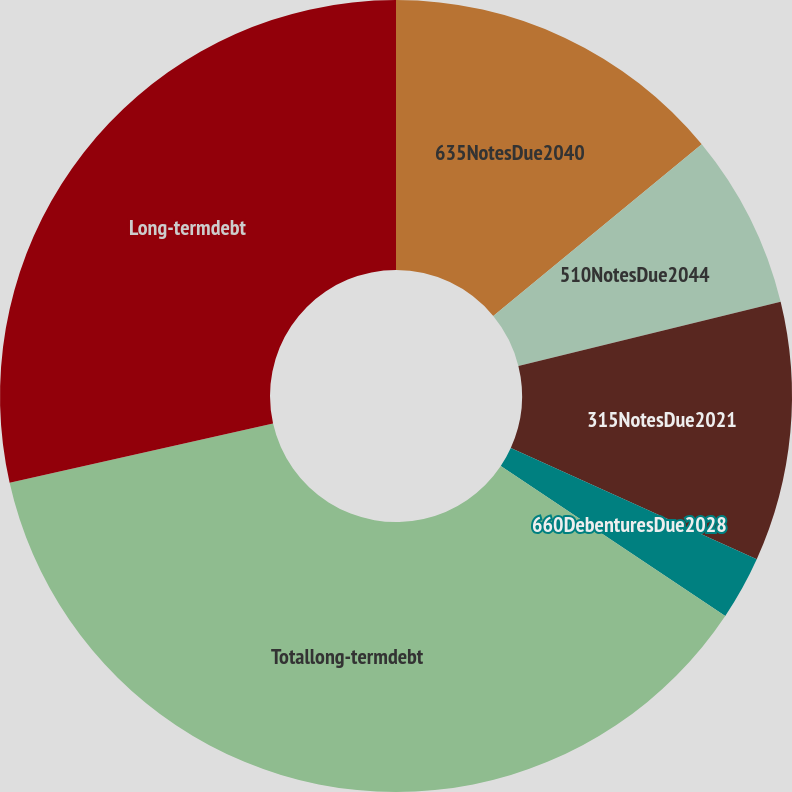<chart> <loc_0><loc_0><loc_500><loc_500><pie_chart><fcel>635NotesDue2040<fcel>510NotesDue2044<fcel>315NotesDue2021<fcel>660DebenturesDue2028<fcel>Totallong-termdebt<fcel>Long-termdebt<nl><fcel>14.04%<fcel>7.14%<fcel>10.59%<fcel>2.61%<fcel>37.11%<fcel>28.52%<nl></chart> 